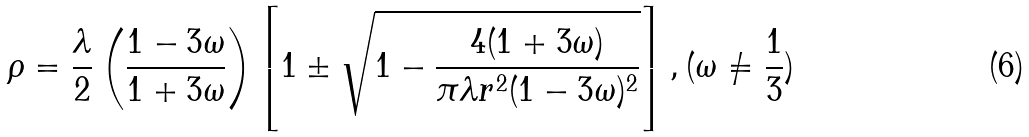Convert formula to latex. <formula><loc_0><loc_0><loc_500><loc_500>\rho = \frac { \lambda } { 2 } \left ( \frac { 1 - 3 \omega } { 1 + 3 \omega } \right ) \left [ 1 \pm \sqrt { 1 - \frac { 4 ( 1 + 3 \omega ) } { \pi \lambda r ^ { 2 } ( 1 - 3 \omega ) ^ { 2 } } } \right ] , ( \omega \neq \frac { 1 } { 3 } )</formula> 